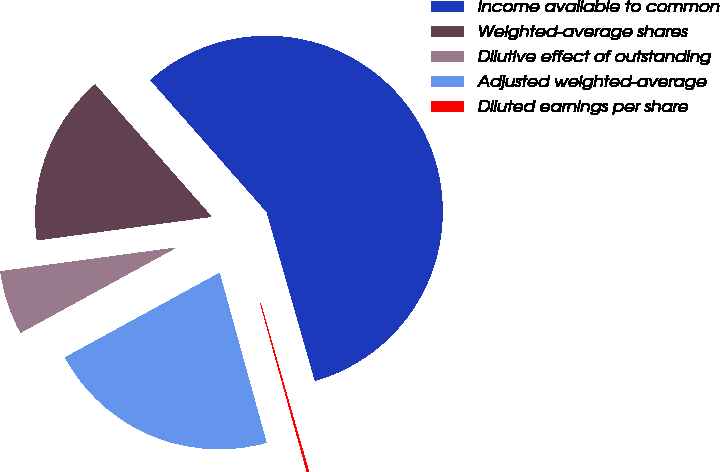<chart> <loc_0><loc_0><loc_500><loc_500><pie_chart><fcel>Income available to common<fcel>Weighted-average shares<fcel>Dilutive effect of outstanding<fcel>Adjusted weighted-average<fcel>Diluted earnings per share<nl><fcel>57.06%<fcel>15.64%<fcel>5.83%<fcel>21.33%<fcel>0.14%<nl></chart> 